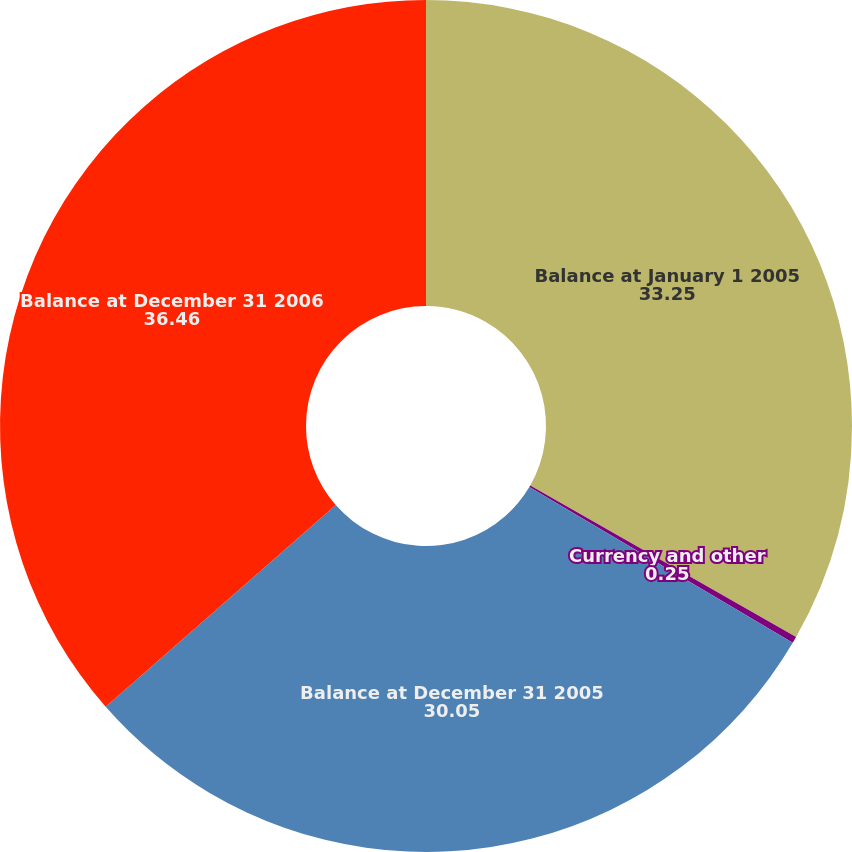Convert chart. <chart><loc_0><loc_0><loc_500><loc_500><pie_chart><fcel>Balance at January 1 2005<fcel>Currency and other<fcel>Balance at December 31 2005<fcel>Balance at December 31 2006<nl><fcel>33.25%<fcel>0.25%<fcel>30.05%<fcel>36.46%<nl></chart> 